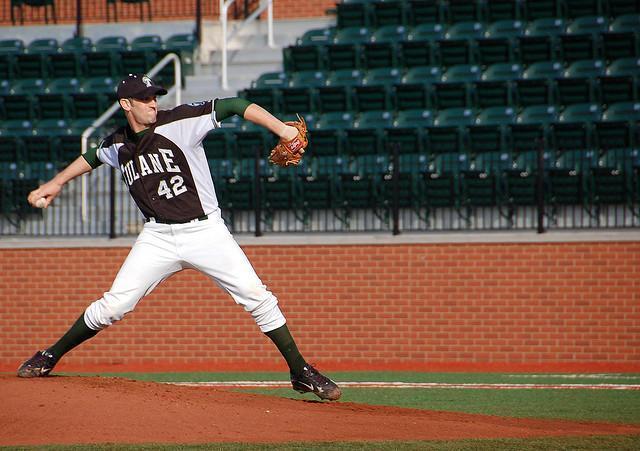How many chairs are there?
Give a very brief answer. 5. How many carrots are on top of the cartoon image?
Give a very brief answer. 0. 